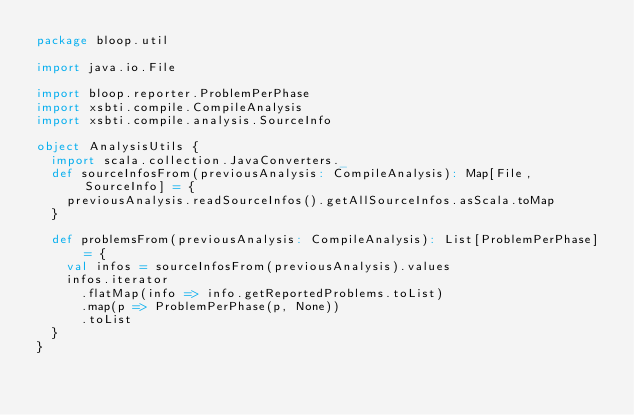Convert code to text. <code><loc_0><loc_0><loc_500><loc_500><_Scala_>package bloop.util

import java.io.File

import bloop.reporter.ProblemPerPhase
import xsbti.compile.CompileAnalysis
import xsbti.compile.analysis.SourceInfo

object AnalysisUtils {
  import scala.collection.JavaConverters._
  def sourceInfosFrom(previousAnalysis: CompileAnalysis): Map[File, SourceInfo] = {
    previousAnalysis.readSourceInfos().getAllSourceInfos.asScala.toMap
  }

  def problemsFrom(previousAnalysis: CompileAnalysis): List[ProblemPerPhase] = {
    val infos = sourceInfosFrom(previousAnalysis).values
    infos.iterator
      .flatMap(info => info.getReportedProblems.toList)
      .map(p => ProblemPerPhase(p, None))
      .toList
  }
}
</code> 